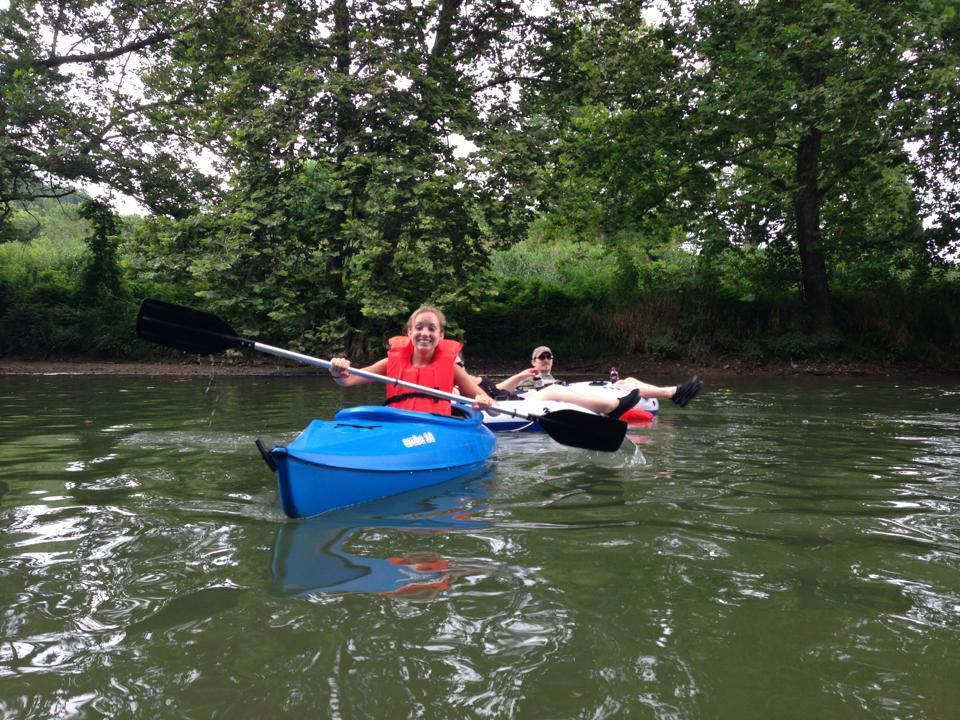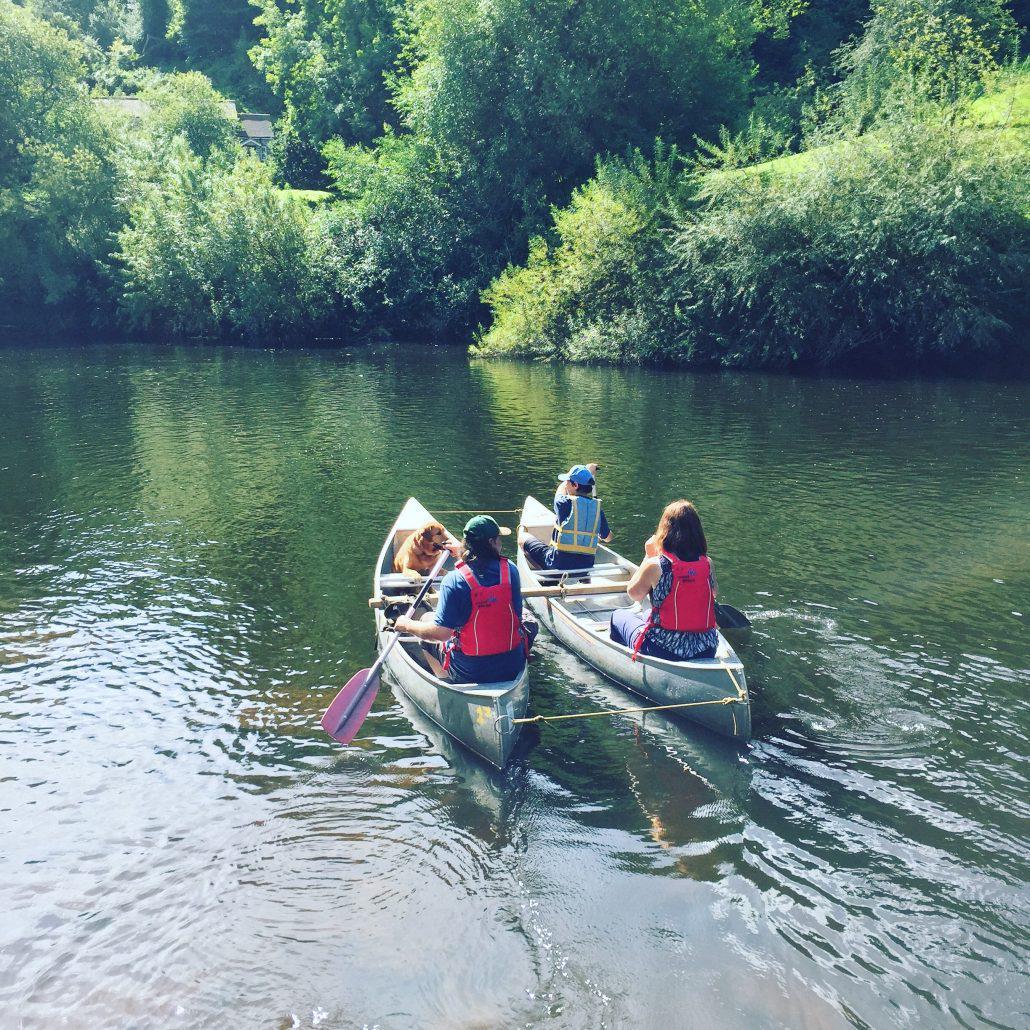The first image is the image on the left, the second image is the image on the right. Examine the images to the left and right. Is the description "In at least one image there a at least two red boats on the shore." accurate? Answer yes or no. No. The first image is the image on the left, the second image is the image on the right. Examine the images to the left and right. Is the description "The combined images include several red and yellow boats pulled up on shore." accurate? Answer yes or no. No. 